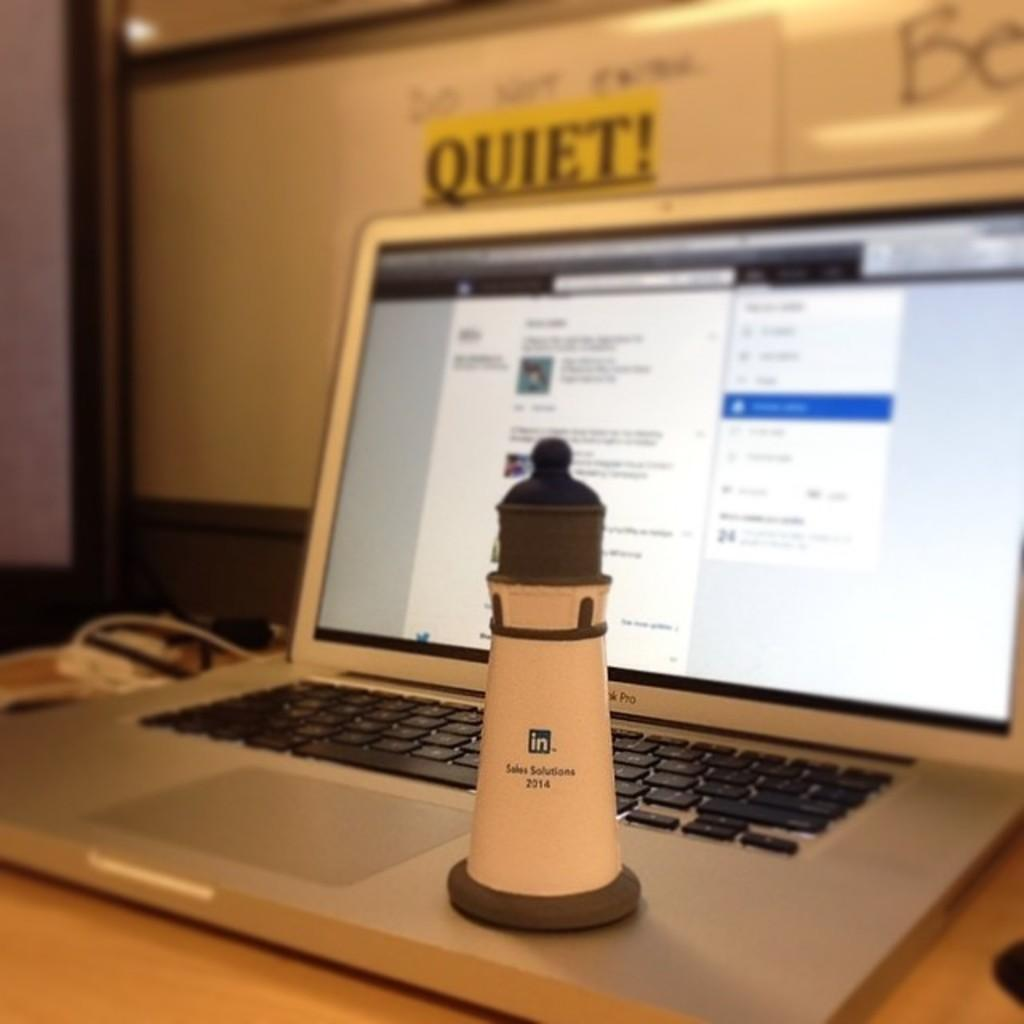What electronic device is present in the image? There is a laptop in the image. What can be seen on the laptop's screen? There is an object visible on the laptop's screen. How would you describe the appearance of the laptop screen's background? The background of the laptop screen is blurry. What type of nest can be seen on the laptop's screen? There is no nest present on the laptop's screen; it displays an object. 